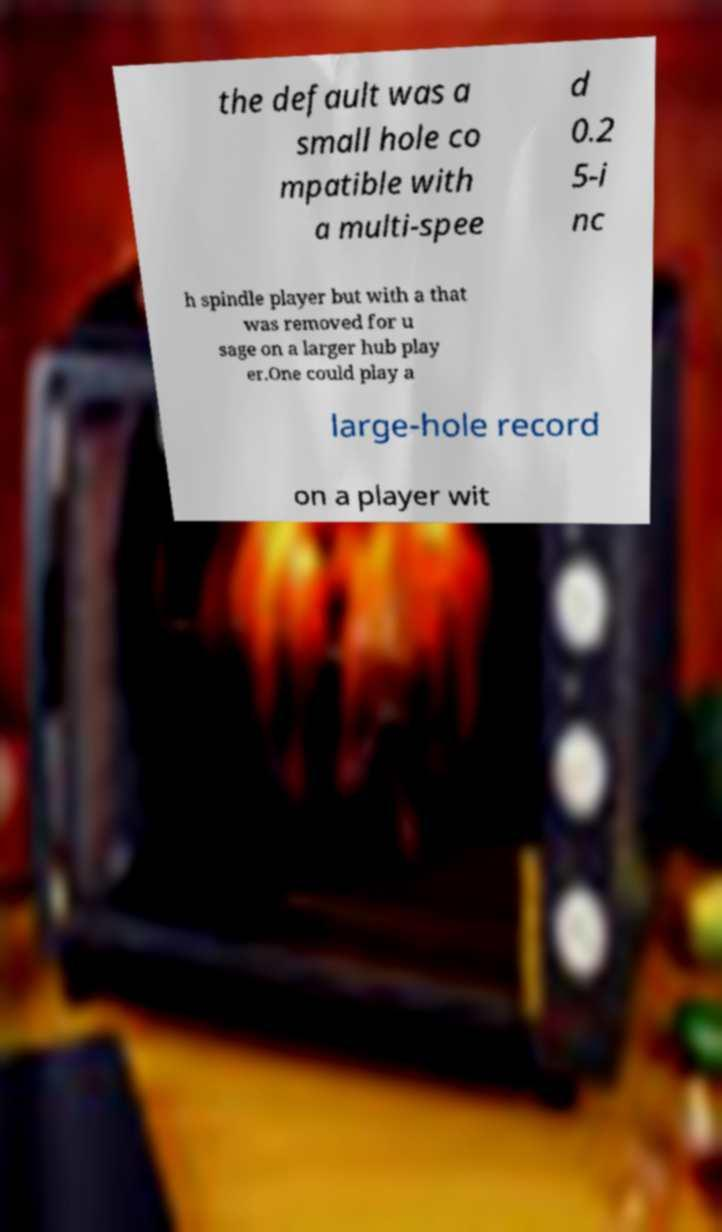Could you assist in decoding the text presented in this image and type it out clearly? the default was a small hole co mpatible with a multi-spee d 0.2 5-i nc h spindle player but with a that was removed for u sage on a larger hub play er.One could play a large-hole record on a player wit 